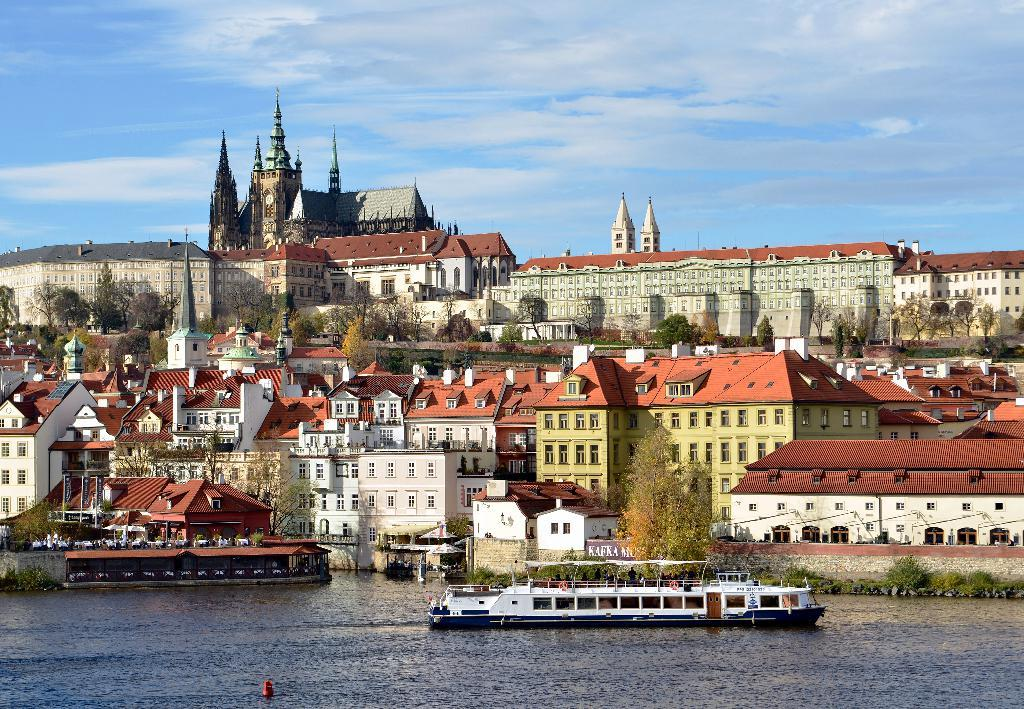What is the main subject of the image? There is a ship in the image. Where is the ship located? The ship is on the water. What other structures can be seen in the image? There are buildings and trees in the image. What is visible in the sky? Clouds are visible in the sky. What type of knife is being used to cut the pan in the image? There is no knife or pan present in the image; it features a ship on the water with buildings, trees, and clouds in the background. 